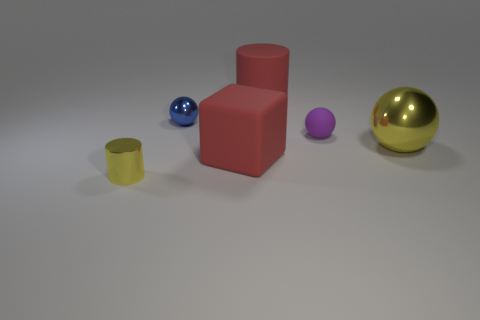Add 4 tiny yellow metallic cylinders. How many objects exist? 10 Subtract all cubes. How many objects are left? 5 Subtract all big yellow shiny cylinders. Subtract all rubber objects. How many objects are left? 3 Add 4 tiny objects. How many tiny objects are left? 7 Add 4 big objects. How many big objects exist? 7 Subtract 0 cyan cubes. How many objects are left? 6 